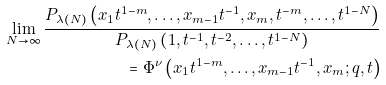<formula> <loc_0><loc_0><loc_500><loc_500>\lim _ { N \rightarrow \infty } { \frac { P _ { \lambda ( N ) } \left ( x _ { 1 } t ^ { 1 - m } , \dots , x _ { m - 1 } t ^ { - 1 } , x _ { m } , t ^ { - m } , \dots , t ^ { 1 - N } \right ) } { P _ { \lambda ( N ) } \left ( 1 , t ^ { - 1 } , t ^ { - 2 } , \dots , t ^ { 1 - N } \right ) } } \\ = \Phi ^ { \nu } \left ( x _ { 1 } t ^ { 1 - m } , \dots , x _ { m - 1 } t ^ { - 1 } , x _ { m } ; q , t \right )</formula> 